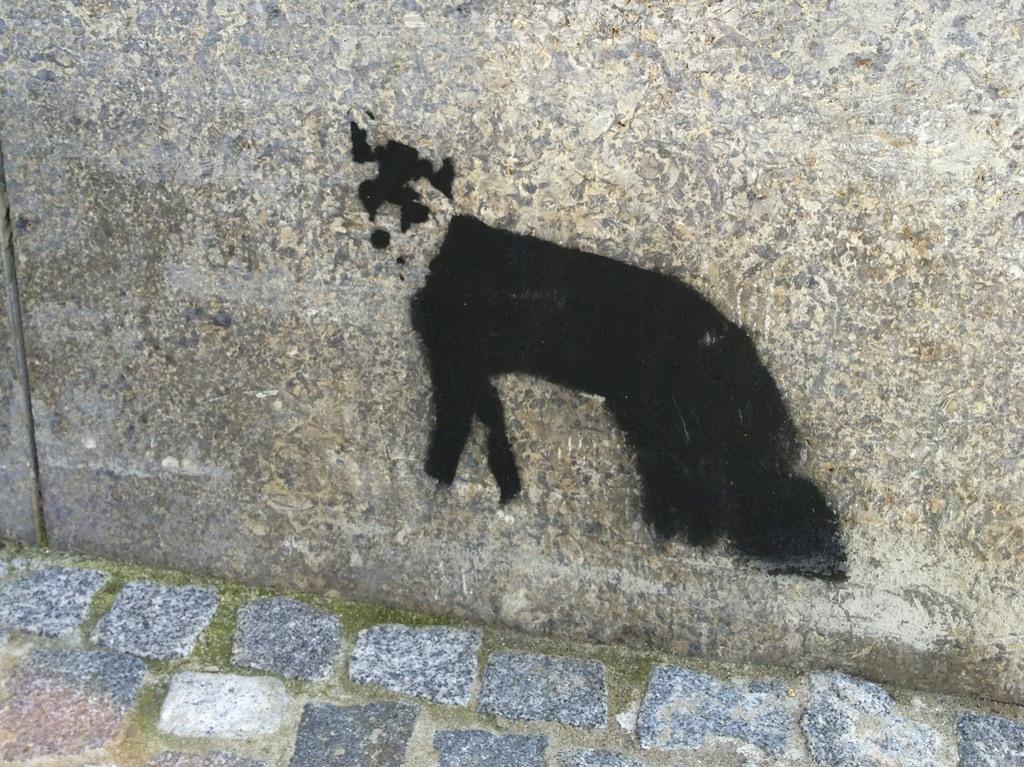Describe this image in one or two sentences. In this picture it looks like a painting on the wall. It is in black color. 